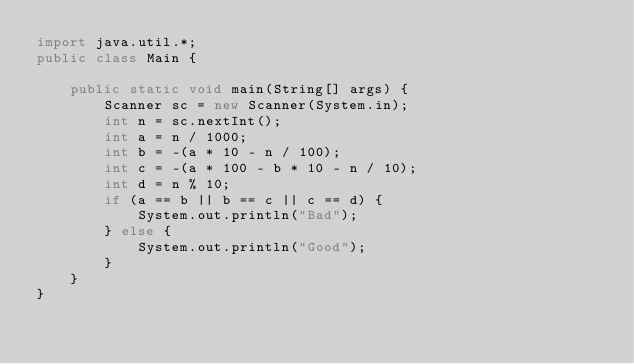<code> <loc_0><loc_0><loc_500><loc_500><_Java_>import java.util.*;
public class Main {

    public static void main(String[] args) {
        Scanner sc = new Scanner(System.in);
        int n = sc.nextInt();
        int a = n / 1000;
        int b = -(a * 10 - n / 100);
        int c = -(a * 100 - b * 10 - n / 10);
        int d = n % 10;
        if (a == b || b == c || c == d) {
            System.out.println("Bad");
        } else {
            System.out.println("Good");
        }
    }
}

</code> 